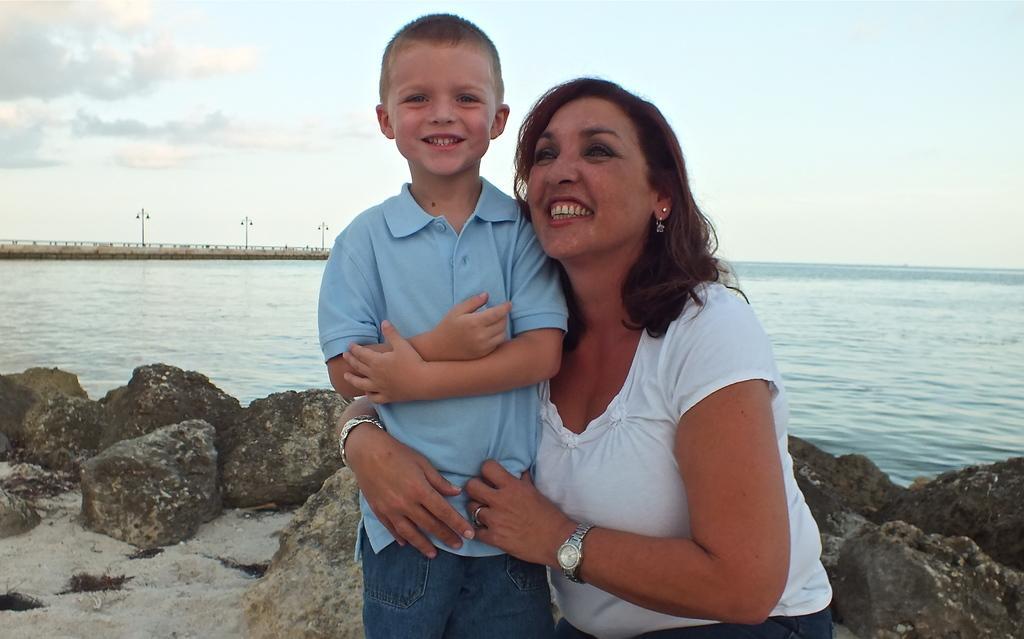Can you describe this image briefly? In this image I can see a woman wearing white colored dress is holding a boy who is wearing blue colored dress. In the background I can see few rocks, the water, few poles and the sky. 